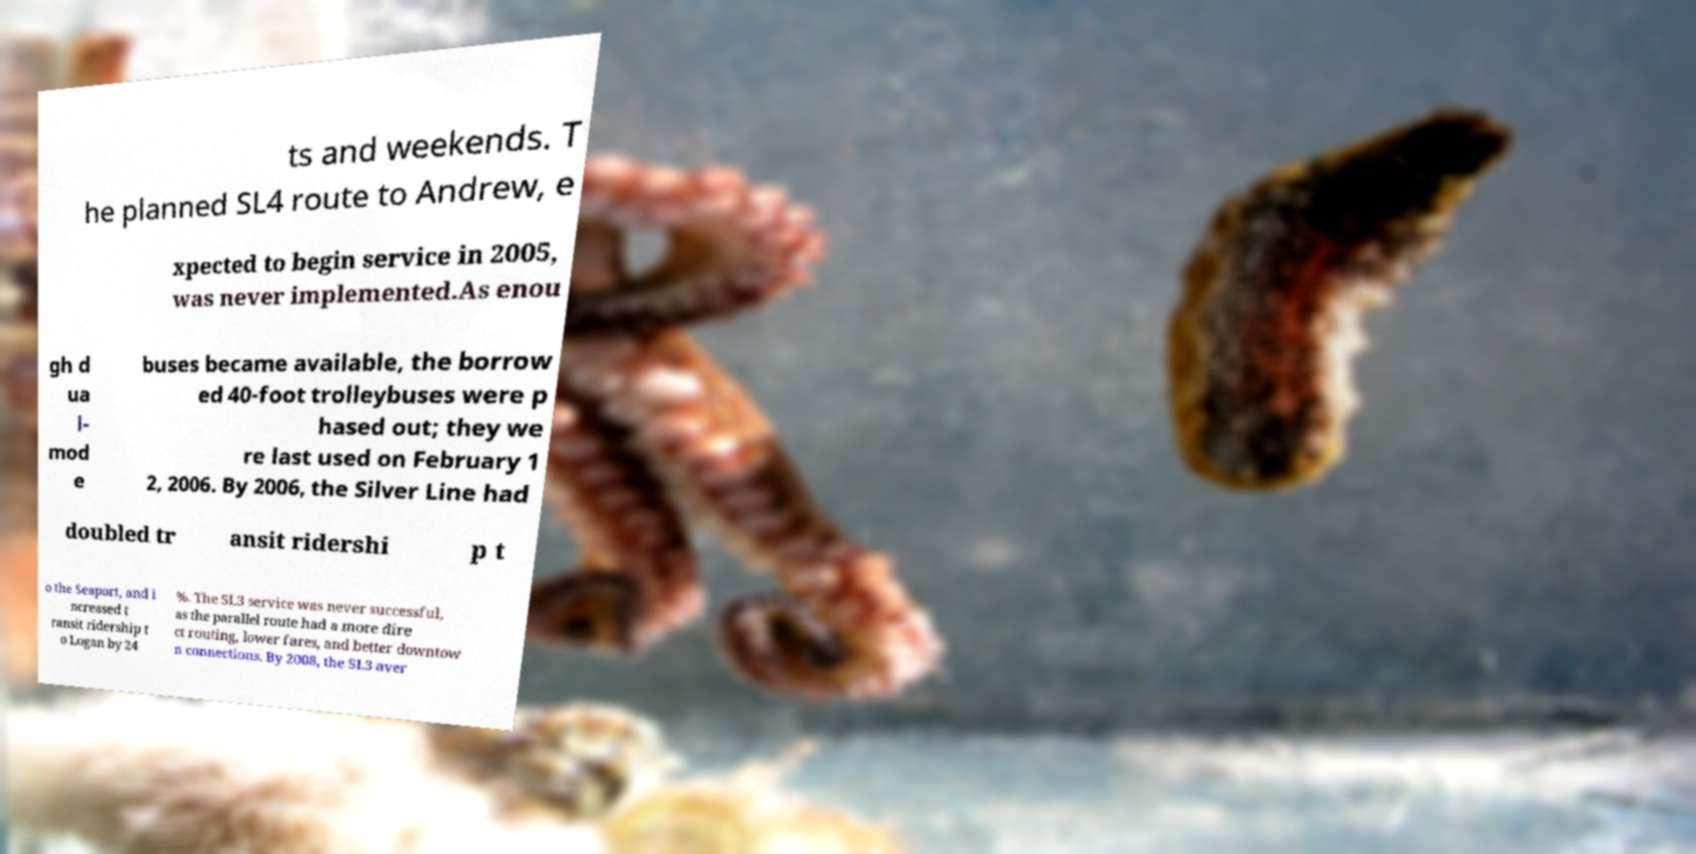There's text embedded in this image that I need extracted. Can you transcribe it verbatim? ts and weekends. T he planned SL4 route to Andrew, e xpected to begin service in 2005, was never implemented.As enou gh d ua l- mod e buses became available, the borrow ed 40-foot trolleybuses were p hased out; they we re last used on February 1 2, 2006. By 2006, the Silver Line had doubled tr ansit ridershi p t o the Seaport, and i ncreased t ransit ridership t o Logan by 24 %. The SL3 service was never successful, as the parallel route had a more dire ct routing, lower fares, and better downtow n connections. By 2008, the SL3 aver 